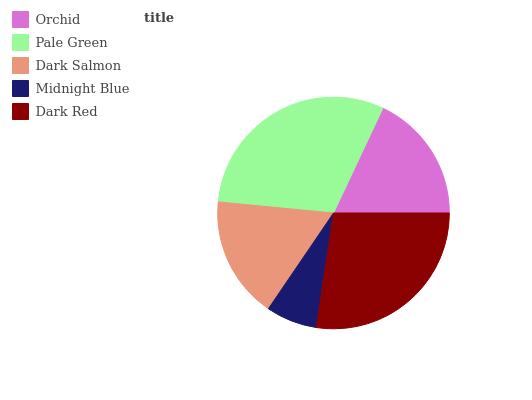Is Midnight Blue the minimum?
Answer yes or no. Yes. Is Pale Green the maximum?
Answer yes or no. Yes. Is Dark Salmon the minimum?
Answer yes or no. No. Is Dark Salmon the maximum?
Answer yes or no. No. Is Pale Green greater than Dark Salmon?
Answer yes or no. Yes. Is Dark Salmon less than Pale Green?
Answer yes or no. Yes. Is Dark Salmon greater than Pale Green?
Answer yes or no. No. Is Pale Green less than Dark Salmon?
Answer yes or no. No. Is Orchid the high median?
Answer yes or no. Yes. Is Orchid the low median?
Answer yes or no. Yes. Is Dark Salmon the high median?
Answer yes or no. No. Is Pale Green the low median?
Answer yes or no. No. 